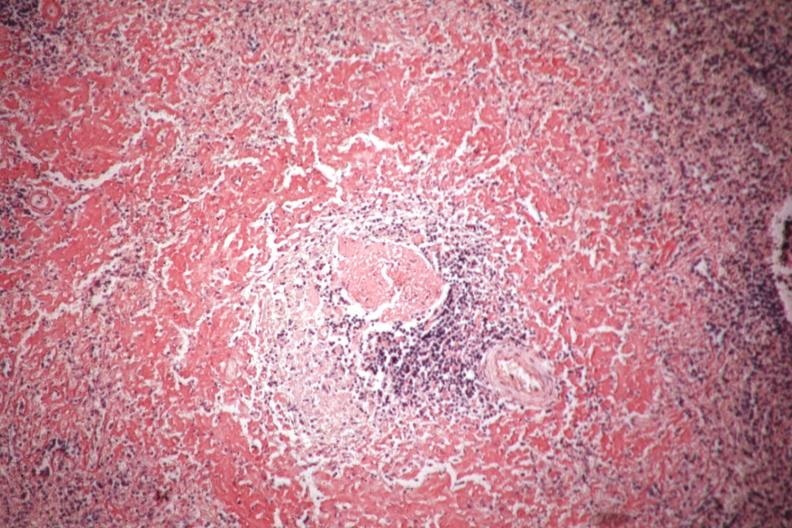what is present?
Answer the question using a single word or phrase. Spleen 